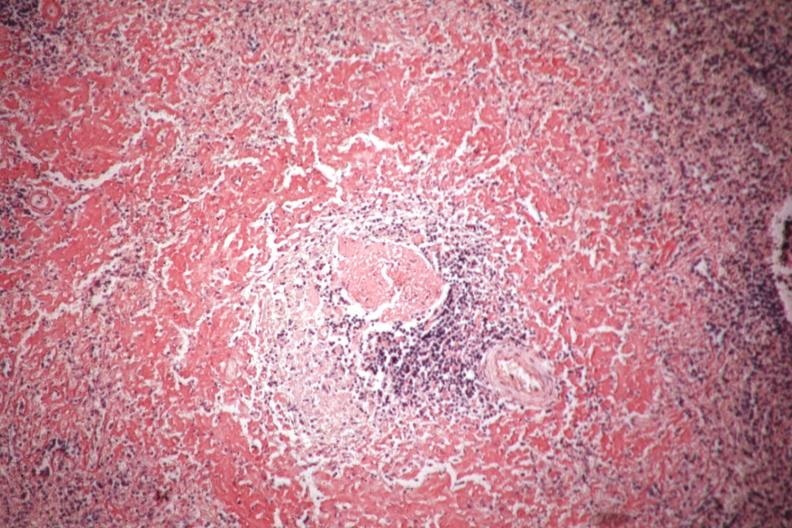what is present?
Answer the question using a single word or phrase. Spleen 